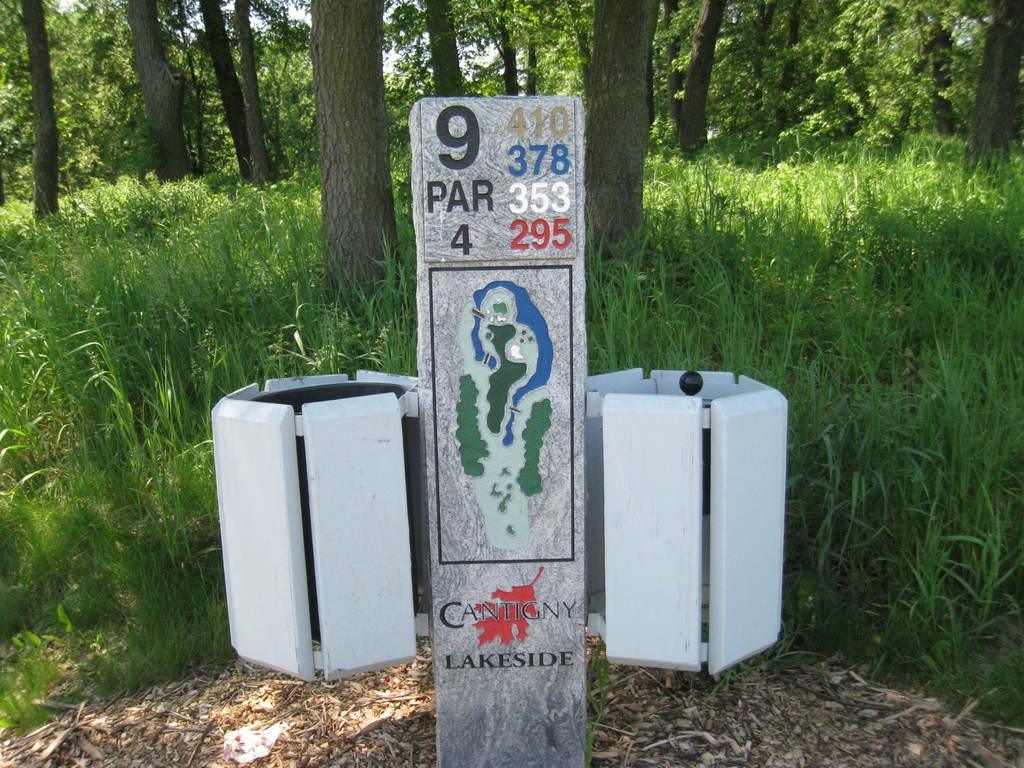What is attached to the pole in the image? There are dustbins attached to the pole in the image. What type of vegetation can be seen in the image? Plants, grass, and trees are visible in the image. Can you describe the texture of the tree bark in the image? The bark of a tree is visible in the image. How many trees are present in the image? There are trees in the image. Who is the creator of the wave visible in the image? There is no wave present in the image, so it is not possible to determine the creator. 